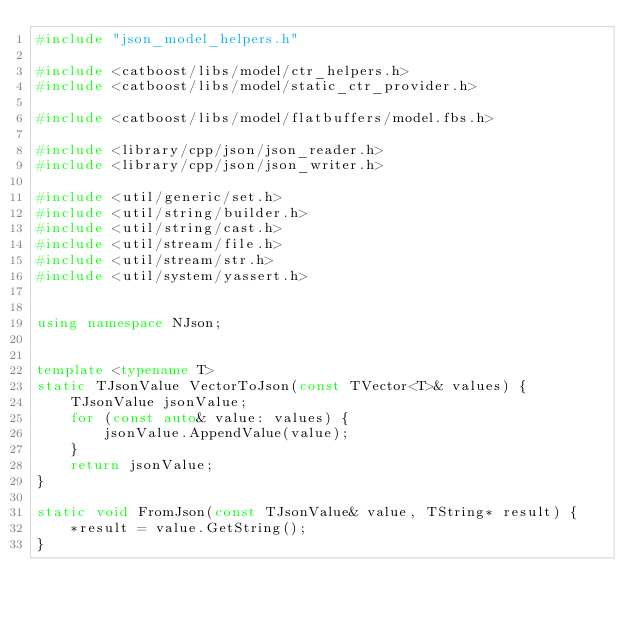<code> <loc_0><loc_0><loc_500><loc_500><_C++_>#include "json_model_helpers.h"

#include <catboost/libs/model/ctr_helpers.h>
#include <catboost/libs/model/static_ctr_provider.h>

#include <catboost/libs/model/flatbuffers/model.fbs.h>

#include <library/cpp/json/json_reader.h>
#include <library/cpp/json/json_writer.h>

#include <util/generic/set.h>
#include <util/string/builder.h>
#include <util/string/cast.h>
#include <util/stream/file.h>
#include <util/stream/str.h>
#include <util/system/yassert.h>


using namespace NJson;


template <typename T>
static TJsonValue VectorToJson(const TVector<T>& values) {
    TJsonValue jsonValue;
    for (const auto& value: values) {
        jsonValue.AppendValue(value);
    }
    return jsonValue;
}

static void FromJson(const TJsonValue& value, TString* result) {
    *result = value.GetString();
}
</code> 